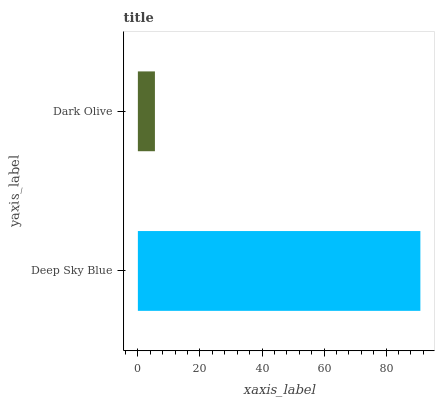Is Dark Olive the minimum?
Answer yes or no. Yes. Is Deep Sky Blue the maximum?
Answer yes or no. Yes. Is Dark Olive the maximum?
Answer yes or no. No. Is Deep Sky Blue greater than Dark Olive?
Answer yes or no. Yes. Is Dark Olive less than Deep Sky Blue?
Answer yes or no. Yes. Is Dark Olive greater than Deep Sky Blue?
Answer yes or no. No. Is Deep Sky Blue less than Dark Olive?
Answer yes or no. No. Is Deep Sky Blue the high median?
Answer yes or no. Yes. Is Dark Olive the low median?
Answer yes or no. Yes. Is Dark Olive the high median?
Answer yes or no. No. Is Deep Sky Blue the low median?
Answer yes or no. No. 